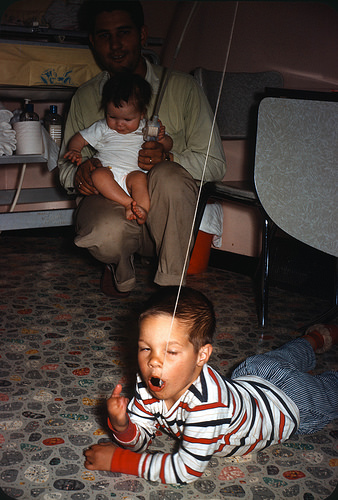<image>
Is the child under the baby? Yes. The child is positioned underneath the baby, with the baby above it in the vertical space. 